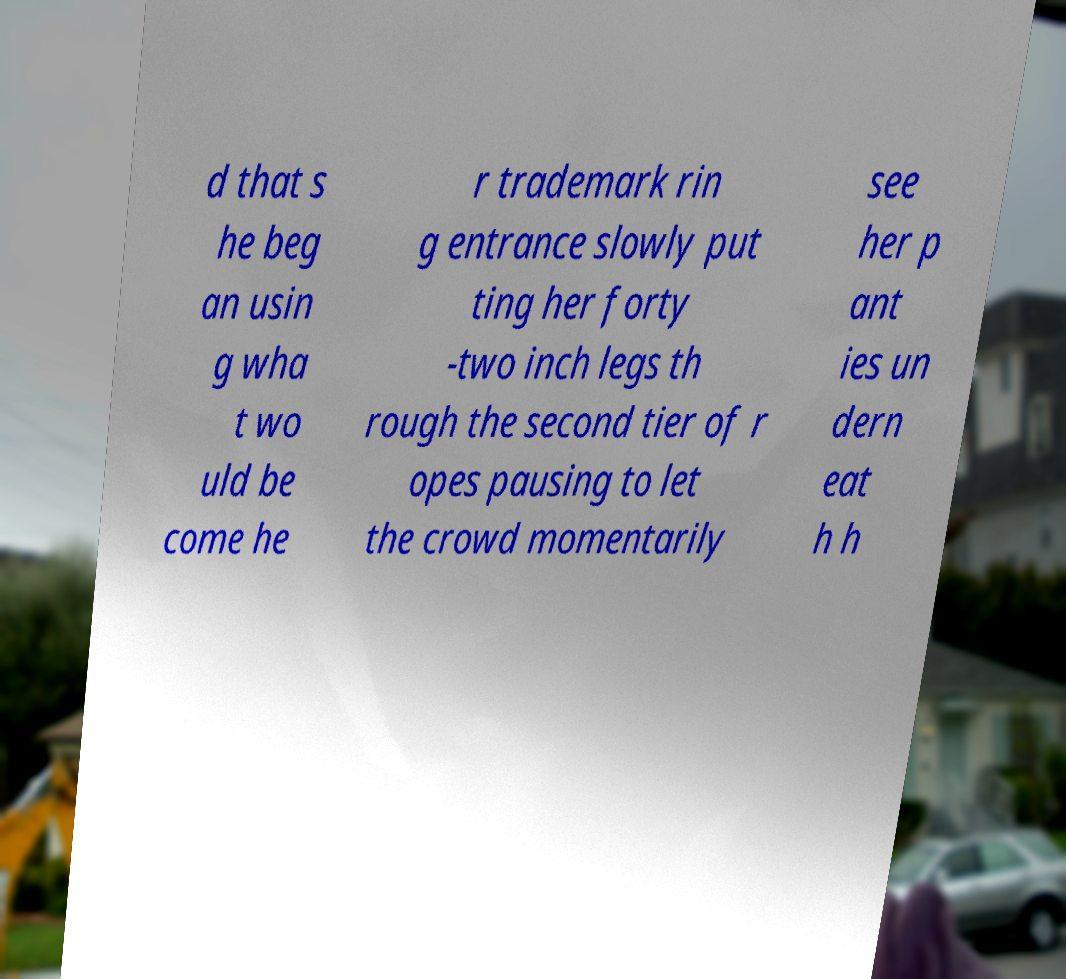Could you assist in decoding the text presented in this image and type it out clearly? d that s he beg an usin g wha t wo uld be come he r trademark rin g entrance slowly put ting her forty -two inch legs th rough the second tier of r opes pausing to let the crowd momentarily see her p ant ies un dern eat h h 